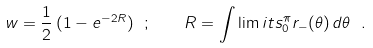<formula> <loc_0><loc_0><loc_500><loc_500>w = \frac { 1 } { 2 } \, ( 1 - e ^ { - 2 R } ) \ ; \quad R = \int \lim i t s _ { 0 } ^ { \pi } r _ { - } ( \theta ) \, d \theta \ .</formula> 